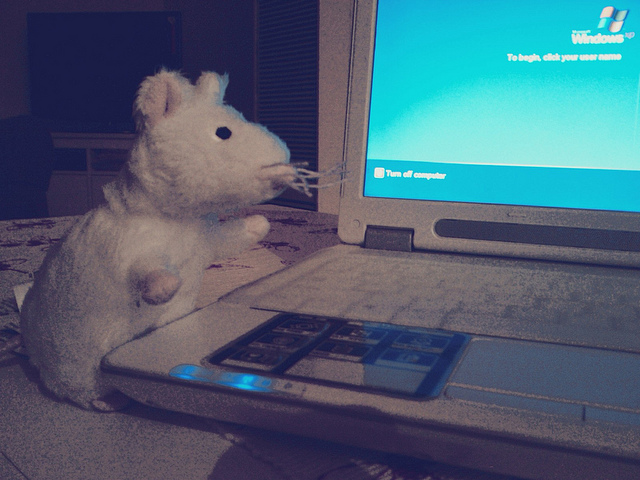Identify the text displayed in this image. Windows Turn Computer Your click begin tO 